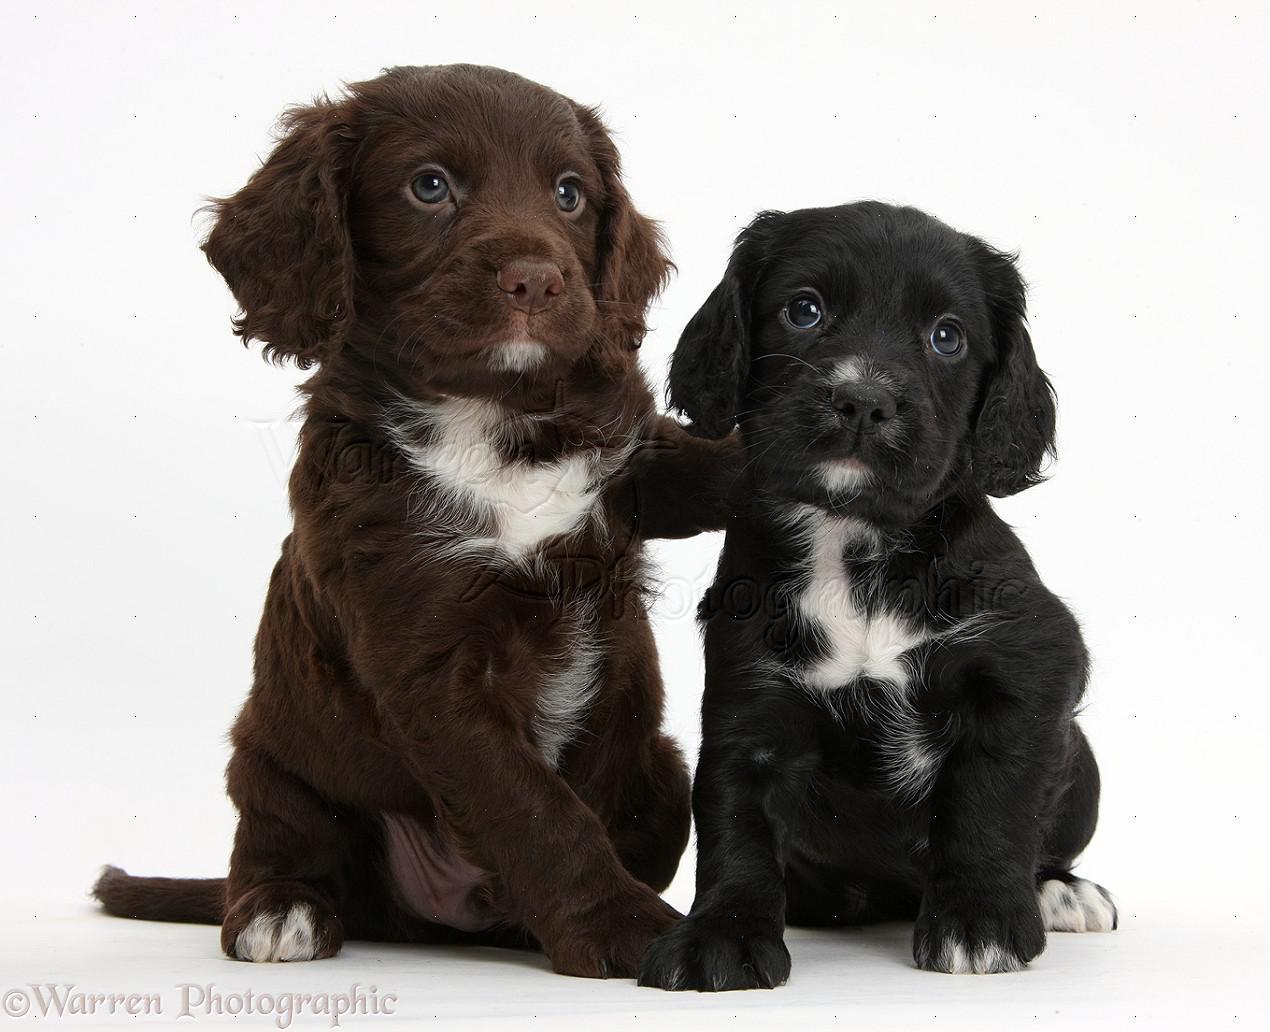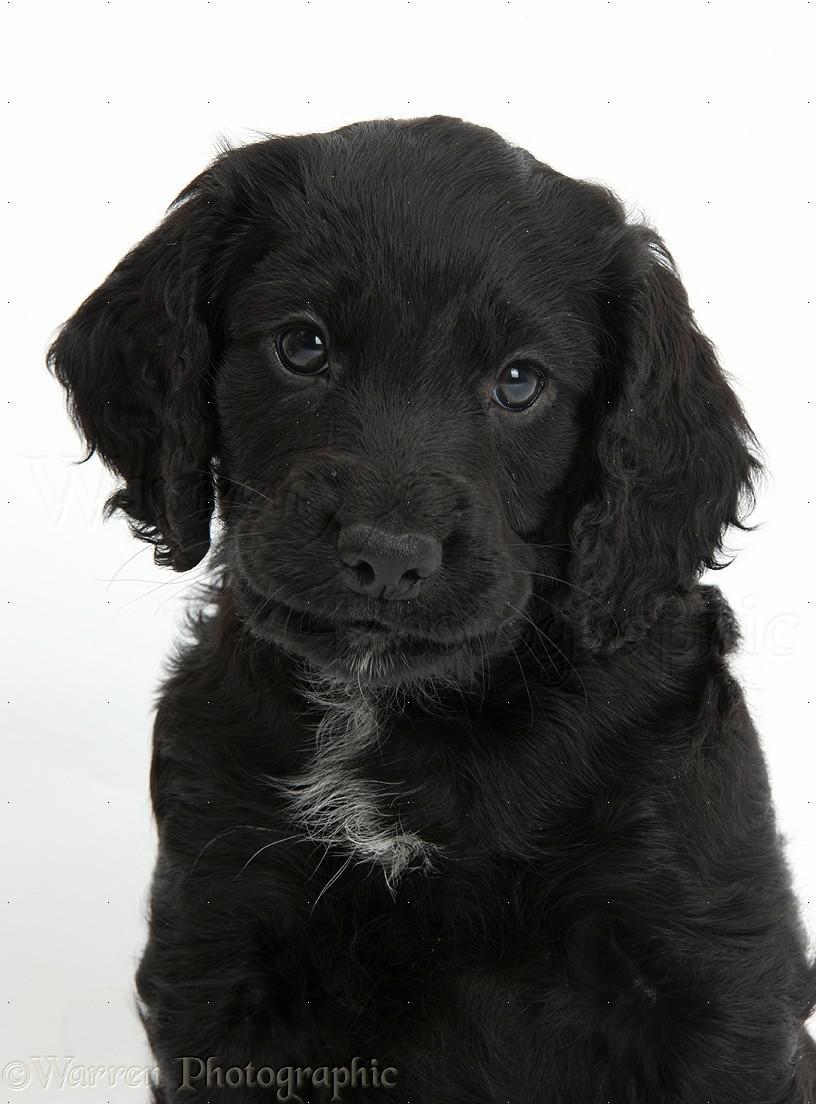The first image is the image on the left, the second image is the image on the right. Evaluate the accuracy of this statement regarding the images: "Two puppies sit together in the image on the left.". Is it true? Answer yes or no. Yes. The first image is the image on the left, the second image is the image on the right. Analyze the images presented: Is the assertion "The left image contains two dark dogs." valid? Answer yes or no. Yes. 